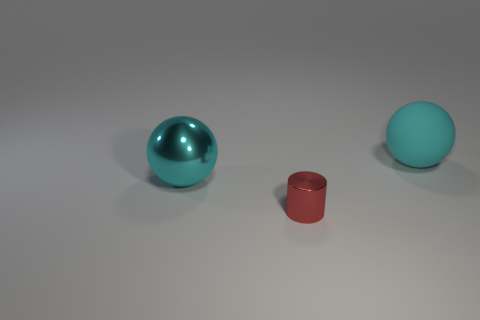Add 2 small shiny objects. How many objects exist? 5 Subtract all spheres. How many objects are left? 1 Add 3 big blocks. How many big blocks exist? 3 Subtract 1 cyan balls. How many objects are left? 2 Subtract all small rubber blocks. Subtract all small red metal things. How many objects are left? 2 Add 3 tiny things. How many tiny things are left? 4 